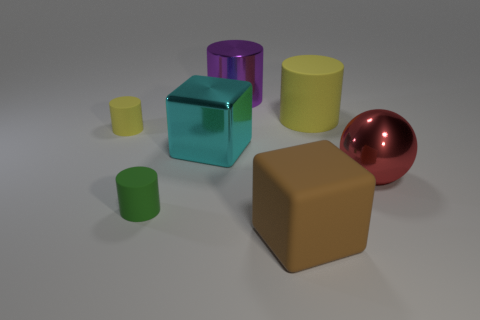Subtract all rubber cylinders. How many cylinders are left? 1 Subtract all brown cubes. How many cubes are left? 1 Subtract all cylinders. How many objects are left? 3 Subtract 1 balls. How many balls are left? 0 Subtract all large rubber objects. Subtract all metal things. How many objects are left? 2 Add 6 rubber cylinders. How many rubber cylinders are left? 9 Add 2 small brown blocks. How many small brown blocks exist? 2 Add 2 big purple metallic objects. How many objects exist? 9 Subtract 0 gray cylinders. How many objects are left? 7 Subtract all green cylinders. Subtract all green blocks. How many cylinders are left? 3 